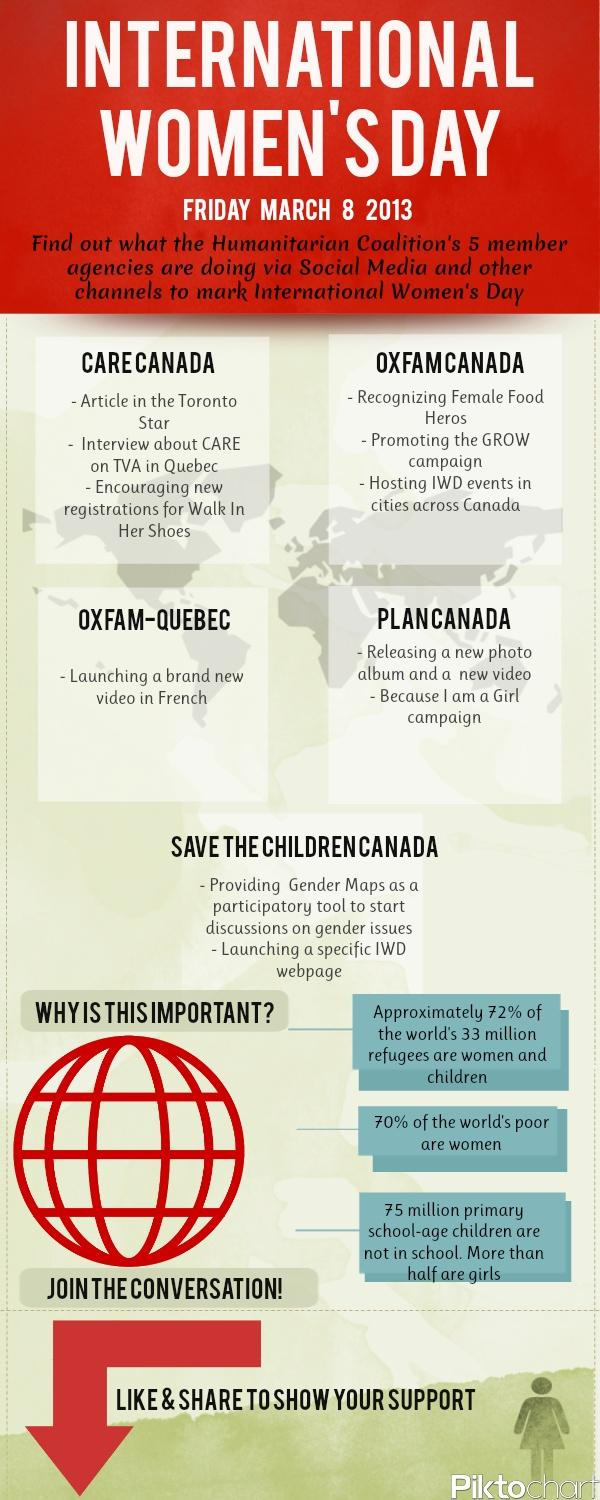Indicate a few pertinent items in this graphic. The article will be written by CARE Canada and featured in the Toronto Star for International Women's Day. Save The Children Canada is launching a specific International Women's Day webpage. OXFAM CANADA is promoting the GROW campaign. I am a Girl campaign is promoted by Plan Canada for International Women's Day. Plan Canada is set to release a new photo album and video. 